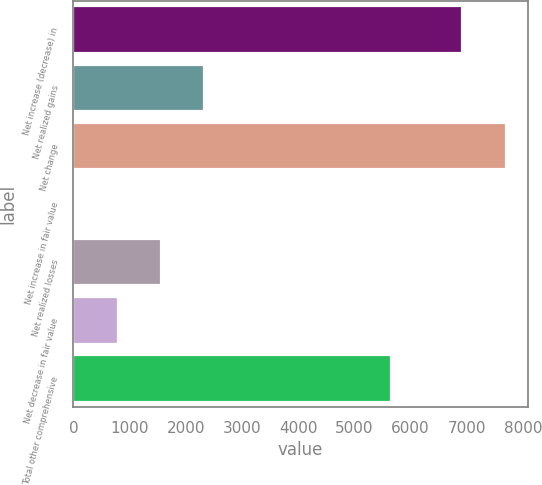Convert chart. <chart><loc_0><loc_0><loc_500><loc_500><bar_chart><fcel>Net increase (decrease) in<fcel>Net realized gains<fcel>Net change<fcel>Net increase in fair value<fcel>Net realized losses<fcel>Net decrease in fair value<fcel>Total other comprehensive<nl><fcel>6912<fcel>2324<fcel>7700<fcel>20<fcel>1556<fcel>788<fcel>5660<nl></chart> 